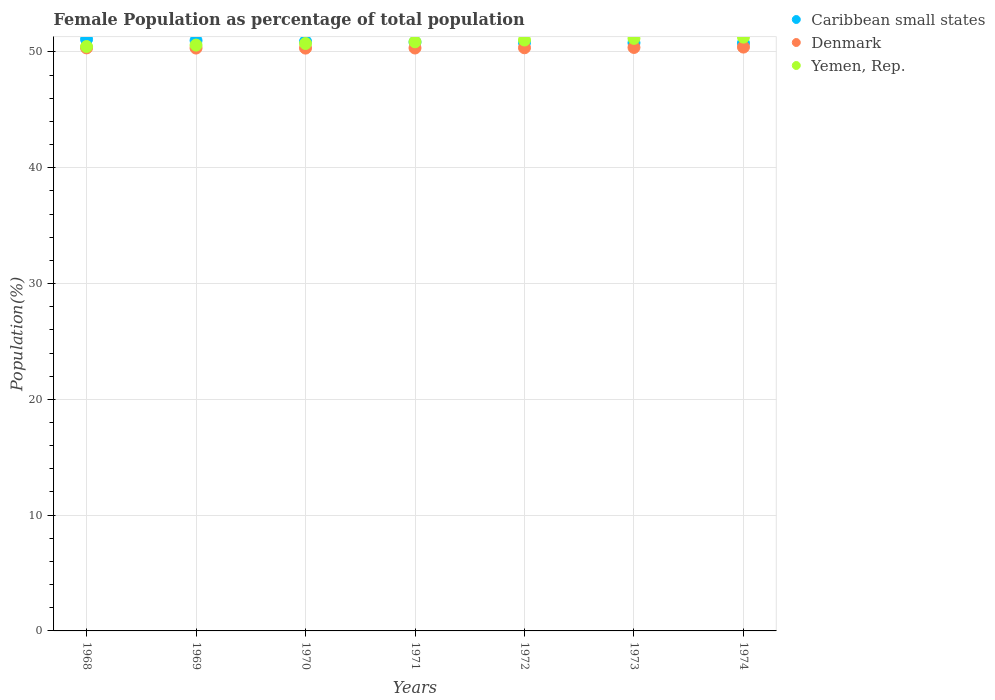How many different coloured dotlines are there?
Your answer should be very brief. 3. Is the number of dotlines equal to the number of legend labels?
Offer a very short reply. Yes. What is the female population in in Denmark in 1968?
Offer a terse response. 50.35. Across all years, what is the maximum female population in in Yemen, Rep.?
Give a very brief answer. 51.28. Across all years, what is the minimum female population in in Denmark?
Offer a very short reply. 50.33. In which year was the female population in in Caribbean small states maximum?
Provide a succinct answer. 1968. What is the total female population in in Denmark in the graph?
Provide a short and direct response. 352.52. What is the difference between the female population in in Yemen, Rep. in 1970 and that in 1973?
Your response must be concise. -0.44. What is the difference between the female population in in Caribbean small states in 1969 and the female population in in Yemen, Rep. in 1971?
Make the answer very short. 0.11. What is the average female population in in Denmark per year?
Offer a very short reply. 50.36. In the year 1971, what is the difference between the female population in in Yemen, Rep. and female population in in Caribbean small states?
Keep it short and to the point. 0.03. What is the ratio of the female population in in Yemen, Rep. in 1972 to that in 1973?
Your response must be concise. 1. Is the difference between the female population in in Yemen, Rep. in 1971 and 1973 greater than the difference between the female population in in Caribbean small states in 1971 and 1973?
Give a very brief answer. No. What is the difference between the highest and the second highest female population in in Denmark?
Offer a terse response. 0.03. What is the difference between the highest and the lowest female population in in Yemen, Rep.?
Offer a very short reply. 0.81. In how many years, is the female population in in Yemen, Rep. greater than the average female population in in Yemen, Rep. taken over all years?
Make the answer very short. 3. Is the female population in in Denmark strictly greater than the female population in in Yemen, Rep. over the years?
Keep it short and to the point. No. How many years are there in the graph?
Provide a short and direct response. 7. Are the values on the major ticks of Y-axis written in scientific E-notation?
Your answer should be very brief. No. Does the graph contain any zero values?
Provide a short and direct response. No. Does the graph contain grids?
Your response must be concise. Yes. What is the title of the graph?
Your answer should be very brief. Female Population as percentage of total population. Does "New Zealand" appear as one of the legend labels in the graph?
Offer a terse response. No. What is the label or title of the Y-axis?
Give a very brief answer. Population(%). What is the Population(%) in Caribbean small states in 1968?
Keep it short and to the point. 51.09. What is the Population(%) in Denmark in 1968?
Give a very brief answer. 50.35. What is the Population(%) in Yemen, Rep. in 1968?
Provide a short and direct response. 50.46. What is the Population(%) in Caribbean small states in 1969?
Provide a short and direct response. 50.99. What is the Population(%) of Denmark in 1969?
Provide a short and direct response. 50.33. What is the Population(%) of Yemen, Rep. in 1969?
Your answer should be compact. 50.59. What is the Population(%) in Caribbean small states in 1970?
Your answer should be very brief. 50.91. What is the Population(%) of Denmark in 1970?
Give a very brief answer. 50.33. What is the Population(%) of Yemen, Rep. in 1970?
Keep it short and to the point. 50.73. What is the Population(%) in Caribbean small states in 1971?
Provide a succinct answer. 50.85. What is the Population(%) in Denmark in 1971?
Offer a terse response. 50.34. What is the Population(%) of Yemen, Rep. in 1971?
Your answer should be compact. 50.88. What is the Population(%) in Caribbean small states in 1972?
Provide a short and direct response. 50.81. What is the Population(%) in Denmark in 1972?
Your answer should be compact. 50.36. What is the Population(%) of Yemen, Rep. in 1972?
Ensure brevity in your answer.  51.03. What is the Population(%) in Caribbean small states in 1973?
Provide a short and direct response. 50.78. What is the Population(%) of Denmark in 1973?
Keep it short and to the point. 50.39. What is the Population(%) of Yemen, Rep. in 1973?
Make the answer very short. 51.17. What is the Population(%) of Caribbean small states in 1974?
Your answer should be very brief. 50.76. What is the Population(%) in Denmark in 1974?
Offer a terse response. 50.42. What is the Population(%) of Yemen, Rep. in 1974?
Provide a short and direct response. 51.28. Across all years, what is the maximum Population(%) in Caribbean small states?
Your response must be concise. 51.09. Across all years, what is the maximum Population(%) in Denmark?
Keep it short and to the point. 50.42. Across all years, what is the maximum Population(%) of Yemen, Rep.?
Your response must be concise. 51.28. Across all years, what is the minimum Population(%) in Caribbean small states?
Your answer should be very brief. 50.76. Across all years, what is the minimum Population(%) in Denmark?
Keep it short and to the point. 50.33. Across all years, what is the minimum Population(%) in Yemen, Rep.?
Make the answer very short. 50.46. What is the total Population(%) of Caribbean small states in the graph?
Ensure brevity in your answer.  356.18. What is the total Population(%) of Denmark in the graph?
Provide a succinct answer. 352.52. What is the total Population(%) in Yemen, Rep. in the graph?
Offer a terse response. 356.14. What is the difference between the Population(%) of Caribbean small states in 1968 and that in 1969?
Ensure brevity in your answer.  0.1. What is the difference between the Population(%) in Denmark in 1968 and that in 1969?
Your response must be concise. 0.02. What is the difference between the Population(%) of Yemen, Rep. in 1968 and that in 1969?
Give a very brief answer. -0.13. What is the difference between the Population(%) of Caribbean small states in 1968 and that in 1970?
Offer a very short reply. 0.18. What is the difference between the Population(%) in Denmark in 1968 and that in 1970?
Provide a short and direct response. 0.02. What is the difference between the Population(%) of Yemen, Rep. in 1968 and that in 1970?
Your answer should be very brief. -0.26. What is the difference between the Population(%) in Caribbean small states in 1968 and that in 1971?
Provide a short and direct response. 0.24. What is the difference between the Population(%) in Denmark in 1968 and that in 1971?
Ensure brevity in your answer.  0.01. What is the difference between the Population(%) of Yemen, Rep. in 1968 and that in 1971?
Offer a terse response. -0.41. What is the difference between the Population(%) of Caribbean small states in 1968 and that in 1972?
Your answer should be very brief. 0.28. What is the difference between the Population(%) of Denmark in 1968 and that in 1972?
Keep it short and to the point. -0.01. What is the difference between the Population(%) of Yemen, Rep. in 1968 and that in 1972?
Your response must be concise. -0.57. What is the difference between the Population(%) of Caribbean small states in 1968 and that in 1973?
Your answer should be compact. 0.3. What is the difference between the Population(%) of Denmark in 1968 and that in 1973?
Offer a terse response. -0.04. What is the difference between the Population(%) of Yemen, Rep. in 1968 and that in 1973?
Your answer should be very brief. -0.71. What is the difference between the Population(%) in Caribbean small states in 1968 and that in 1974?
Provide a short and direct response. 0.33. What is the difference between the Population(%) of Denmark in 1968 and that in 1974?
Give a very brief answer. -0.07. What is the difference between the Population(%) of Yemen, Rep. in 1968 and that in 1974?
Give a very brief answer. -0.81. What is the difference between the Population(%) of Caribbean small states in 1969 and that in 1970?
Ensure brevity in your answer.  0.08. What is the difference between the Population(%) of Denmark in 1969 and that in 1970?
Keep it short and to the point. 0. What is the difference between the Population(%) in Yemen, Rep. in 1969 and that in 1970?
Offer a terse response. -0.14. What is the difference between the Population(%) of Caribbean small states in 1969 and that in 1971?
Make the answer very short. 0.14. What is the difference between the Population(%) in Denmark in 1969 and that in 1971?
Give a very brief answer. -0.01. What is the difference between the Population(%) in Yemen, Rep. in 1969 and that in 1971?
Your response must be concise. -0.28. What is the difference between the Population(%) in Caribbean small states in 1969 and that in 1972?
Provide a short and direct response. 0.18. What is the difference between the Population(%) of Denmark in 1969 and that in 1972?
Ensure brevity in your answer.  -0.03. What is the difference between the Population(%) in Yemen, Rep. in 1969 and that in 1972?
Provide a succinct answer. -0.44. What is the difference between the Population(%) of Caribbean small states in 1969 and that in 1973?
Keep it short and to the point. 0.2. What is the difference between the Population(%) in Denmark in 1969 and that in 1973?
Give a very brief answer. -0.05. What is the difference between the Population(%) of Yemen, Rep. in 1969 and that in 1973?
Provide a short and direct response. -0.58. What is the difference between the Population(%) in Caribbean small states in 1969 and that in 1974?
Give a very brief answer. 0.23. What is the difference between the Population(%) in Denmark in 1969 and that in 1974?
Your answer should be compact. -0.08. What is the difference between the Population(%) of Yemen, Rep. in 1969 and that in 1974?
Offer a very short reply. -0.69. What is the difference between the Population(%) of Caribbean small states in 1970 and that in 1971?
Provide a short and direct response. 0.06. What is the difference between the Population(%) of Denmark in 1970 and that in 1971?
Ensure brevity in your answer.  -0.01. What is the difference between the Population(%) in Yemen, Rep. in 1970 and that in 1971?
Provide a short and direct response. -0.15. What is the difference between the Population(%) of Caribbean small states in 1970 and that in 1972?
Your answer should be very brief. 0.1. What is the difference between the Population(%) in Denmark in 1970 and that in 1972?
Give a very brief answer. -0.03. What is the difference between the Population(%) of Yemen, Rep. in 1970 and that in 1972?
Give a very brief answer. -0.3. What is the difference between the Population(%) of Caribbean small states in 1970 and that in 1973?
Keep it short and to the point. 0.12. What is the difference between the Population(%) in Denmark in 1970 and that in 1973?
Make the answer very short. -0.06. What is the difference between the Population(%) in Yemen, Rep. in 1970 and that in 1973?
Your answer should be compact. -0.44. What is the difference between the Population(%) of Caribbean small states in 1970 and that in 1974?
Keep it short and to the point. 0.14. What is the difference between the Population(%) of Denmark in 1970 and that in 1974?
Give a very brief answer. -0.09. What is the difference between the Population(%) in Yemen, Rep. in 1970 and that in 1974?
Give a very brief answer. -0.55. What is the difference between the Population(%) in Caribbean small states in 1971 and that in 1972?
Provide a short and direct response. 0.04. What is the difference between the Population(%) of Denmark in 1971 and that in 1972?
Offer a very short reply. -0.02. What is the difference between the Population(%) in Yemen, Rep. in 1971 and that in 1972?
Ensure brevity in your answer.  -0.15. What is the difference between the Population(%) of Caribbean small states in 1971 and that in 1973?
Make the answer very short. 0.06. What is the difference between the Population(%) in Denmark in 1971 and that in 1973?
Make the answer very short. -0.05. What is the difference between the Population(%) of Yemen, Rep. in 1971 and that in 1973?
Make the answer very short. -0.3. What is the difference between the Population(%) of Caribbean small states in 1971 and that in 1974?
Your answer should be very brief. 0.09. What is the difference between the Population(%) of Denmark in 1971 and that in 1974?
Make the answer very short. -0.08. What is the difference between the Population(%) in Yemen, Rep. in 1971 and that in 1974?
Your answer should be compact. -0.4. What is the difference between the Population(%) of Caribbean small states in 1972 and that in 1973?
Ensure brevity in your answer.  0.03. What is the difference between the Population(%) in Denmark in 1972 and that in 1973?
Give a very brief answer. -0.03. What is the difference between the Population(%) in Yemen, Rep. in 1972 and that in 1973?
Offer a terse response. -0.14. What is the difference between the Population(%) in Caribbean small states in 1972 and that in 1974?
Offer a terse response. 0.05. What is the difference between the Population(%) of Denmark in 1972 and that in 1974?
Give a very brief answer. -0.06. What is the difference between the Population(%) of Yemen, Rep. in 1972 and that in 1974?
Provide a short and direct response. -0.25. What is the difference between the Population(%) in Caribbean small states in 1973 and that in 1974?
Your response must be concise. 0.02. What is the difference between the Population(%) in Denmark in 1973 and that in 1974?
Provide a short and direct response. -0.03. What is the difference between the Population(%) in Yemen, Rep. in 1973 and that in 1974?
Keep it short and to the point. -0.11. What is the difference between the Population(%) in Caribbean small states in 1968 and the Population(%) in Denmark in 1969?
Offer a very short reply. 0.75. What is the difference between the Population(%) of Caribbean small states in 1968 and the Population(%) of Yemen, Rep. in 1969?
Ensure brevity in your answer.  0.5. What is the difference between the Population(%) of Denmark in 1968 and the Population(%) of Yemen, Rep. in 1969?
Your answer should be compact. -0.24. What is the difference between the Population(%) of Caribbean small states in 1968 and the Population(%) of Denmark in 1970?
Your answer should be very brief. 0.76. What is the difference between the Population(%) in Caribbean small states in 1968 and the Population(%) in Yemen, Rep. in 1970?
Ensure brevity in your answer.  0.36. What is the difference between the Population(%) in Denmark in 1968 and the Population(%) in Yemen, Rep. in 1970?
Your response must be concise. -0.38. What is the difference between the Population(%) in Caribbean small states in 1968 and the Population(%) in Denmark in 1971?
Your answer should be compact. 0.75. What is the difference between the Population(%) in Caribbean small states in 1968 and the Population(%) in Yemen, Rep. in 1971?
Your answer should be compact. 0.21. What is the difference between the Population(%) in Denmark in 1968 and the Population(%) in Yemen, Rep. in 1971?
Your answer should be very brief. -0.53. What is the difference between the Population(%) in Caribbean small states in 1968 and the Population(%) in Denmark in 1972?
Ensure brevity in your answer.  0.73. What is the difference between the Population(%) of Caribbean small states in 1968 and the Population(%) of Yemen, Rep. in 1972?
Your answer should be very brief. 0.06. What is the difference between the Population(%) in Denmark in 1968 and the Population(%) in Yemen, Rep. in 1972?
Offer a terse response. -0.68. What is the difference between the Population(%) in Caribbean small states in 1968 and the Population(%) in Denmark in 1973?
Offer a very short reply. 0.7. What is the difference between the Population(%) in Caribbean small states in 1968 and the Population(%) in Yemen, Rep. in 1973?
Provide a short and direct response. -0.08. What is the difference between the Population(%) of Denmark in 1968 and the Population(%) of Yemen, Rep. in 1973?
Provide a succinct answer. -0.82. What is the difference between the Population(%) of Caribbean small states in 1968 and the Population(%) of Denmark in 1974?
Give a very brief answer. 0.67. What is the difference between the Population(%) in Caribbean small states in 1968 and the Population(%) in Yemen, Rep. in 1974?
Your answer should be very brief. -0.19. What is the difference between the Population(%) in Denmark in 1968 and the Population(%) in Yemen, Rep. in 1974?
Keep it short and to the point. -0.93. What is the difference between the Population(%) in Caribbean small states in 1969 and the Population(%) in Denmark in 1970?
Ensure brevity in your answer.  0.66. What is the difference between the Population(%) in Caribbean small states in 1969 and the Population(%) in Yemen, Rep. in 1970?
Provide a succinct answer. 0.26. What is the difference between the Population(%) in Denmark in 1969 and the Population(%) in Yemen, Rep. in 1970?
Offer a very short reply. -0.39. What is the difference between the Population(%) of Caribbean small states in 1969 and the Population(%) of Denmark in 1971?
Give a very brief answer. 0.65. What is the difference between the Population(%) of Caribbean small states in 1969 and the Population(%) of Yemen, Rep. in 1971?
Ensure brevity in your answer.  0.11. What is the difference between the Population(%) of Denmark in 1969 and the Population(%) of Yemen, Rep. in 1971?
Offer a terse response. -0.54. What is the difference between the Population(%) of Caribbean small states in 1969 and the Population(%) of Denmark in 1972?
Ensure brevity in your answer.  0.63. What is the difference between the Population(%) of Caribbean small states in 1969 and the Population(%) of Yemen, Rep. in 1972?
Your response must be concise. -0.04. What is the difference between the Population(%) in Denmark in 1969 and the Population(%) in Yemen, Rep. in 1972?
Your answer should be very brief. -0.7. What is the difference between the Population(%) in Caribbean small states in 1969 and the Population(%) in Denmark in 1973?
Ensure brevity in your answer.  0.6. What is the difference between the Population(%) in Caribbean small states in 1969 and the Population(%) in Yemen, Rep. in 1973?
Provide a succinct answer. -0.18. What is the difference between the Population(%) of Denmark in 1969 and the Population(%) of Yemen, Rep. in 1973?
Ensure brevity in your answer.  -0.84. What is the difference between the Population(%) in Caribbean small states in 1969 and the Population(%) in Denmark in 1974?
Your answer should be compact. 0.57. What is the difference between the Population(%) of Caribbean small states in 1969 and the Population(%) of Yemen, Rep. in 1974?
Keep it short and to the point. -0.29. What is the difference between the Population(%) in Denmark in 1969 and the Population(%) in Yemen, Rep. in 1974?
Give a very brief answer. -0.94. What is the difference between the Population(%) of Caribbean small states in 1970 and the Population(%) of Denmark in 1971?
Provide a short and direct response. 0.57. What is the difference between the Population(%) of Caribbean small states in 1970 and the Population(%) of Yemen, Rep. in 1971?
Ensure brevity in your answer.  0.03. What is the difference between the Population(%) in Denmark in 1970 and the Population(%) in Yemen, Rep. in 1971?
Your response must be concise. -0.55. What is the difference between the Population(%) of Caribbean small states in 1970 and the Population(%) of Denmark in 1972?
Ensure brevity in your answer.  0.55. What is the difference between the Population(%) of Caribbean small states in 1970 and the Population(%) of Yemen, Rep. in 1972?
Offer a very short reply. -0.12. What is the difference between the Population(%) in Denmark in 1970 and the Population(%) in Yemen, Rep. in 1972?
Your response must be concise. -0.7. What is the difference between the Population(%) of Caribbean small states in 1970 and the Population(%) of Denmark in 1973?
Keep it short and to the point. 0.52. What is the difference between the Population(%) in Caribbean small states in 1970 and the Population(%) in Yemen, Rep. in 1973?
Keep it short and to the point. -0.27. What is the difference between the Population(%) of Denmark in 1970 and the Population(%) of Yemen, Rep. in 1973?
Offer a terse response. -0.84. What is the difference between the Population(%) in Caribbean small states in 1970 and the Population(%) in Denmark in 1974?
Offer a terse response. 0.49. What is the difference between the Population(%) in Caribbean small states in 1970 and the Population(%) in Yemen, Rep. in 1974?
Ensure brevity in your answer.  -0.37. What is the difference between the Population(%) in Denmark in 1970 and the Population(%) in Yemen, Rep. in 1974?
Your answer should be compact. -0.95. What is the difference between the Population(%) of Caribbean small states in 1971 and the Population(%) of Denmark in 1972?
Make the answer very short. 0.49. What is the difference between the Population(%) in Caribbean small states in 1971 and the Population(%) in Yemen, Rep. in 1972?
Your response must be concise. -0.18. What is the difference between the Population(%) of Denmark in 1971 and the Population(%) of Yemen, Rep. in 1972?
Your answer should be very brief. -0.69. What is the difference between the Population(%) in Caribbean small states in 1971 and the Population(%) in Denmark in 1973?
Your response must be concise. 0.46. What is the difference between the Population(%) of Caribbean small states in 1971 and the Population(%) of Yemen, Rep. in 1973?
Offer a very short reply. -0.32. What is the difference between the Population(%) in Denmark in 1971 and the Population(%) in Yemen, Rep. in 1973?
Make the answer very short. -0.83. What is the difference between the Population(%) in Caribbean small states in 1971 and the Population(%) in Denmark in 1974?
Make the answer very short. 0.43. What is the difference between the Population(%) of Caribbean small states in 1971 and the Population(%) of Yemen, Rep. in 1974?
Offer a terse response. -0.43. What is the difference between the Population(%) of Denmark in 1971 and the Population(%) of Yemen, Rep. in 1974?
Provide a succinct answer. -0.94. What is the difference between the Population(%) in Caribbean small states in 1972 and the Population(%) in Denmark in 1973?
Keep it short and to the point. 0.42. What is the difference between the Population(%) in Caribbean small states in 1972 and the Population(%) in Yemen, Rep. in 1973?
Your answer should be very brief. -0.36. What is the difference between the Population(%) of Denmark in 1972 and the Population(%) of Yemen, Rep. in 1973?
Provide a short and direct response. -0.81. What is the difference between the Population(%) in Caribbean small states in 1972 and the Population(%) in Denmark in 1974?
Your answer should be compact. 0.39. What is the difference between the Population(%) in Caribbean small states in 1972 and the Population(%) in Yemen, Rep. in 1974?
Offer a very short reply. -0.47. What is the difference between the Population(%) in Denmark in 1972 and the Population(%) in Yemen, Rep. in 1974?
Your answer should be very brief. -0.92. What is the difference between the Population(%) of Caribbean small states in 1973 and the Population(%) of Denmark in 1974?
Provide a succinct answer. 0.37. What is the difference between the Population(%) of Caribbean small states in 1973 and the Population(%) of Yemen, Rep. in 1974?
Your response must be concise. -0.49. What is the difference between the Population(%) of Denmark in 1973 and the Population(%) of Yemen, Rep. in 1974?
Your response must be concise. -0.89. What is the average Population(%) of Caribbean small states per year?
Your answer should be very brief. 50.88. What is the average Population(%) in Denmark per year?
Provide a short and direct response. 50.36. What is the average Population(%) in Yemen, Rep. per year?
Your answer should be compact. 50.88. In the year 1968, what is the difference between the Population(%) of Caribbean small states and Population(%) of Denmark?
Your answer should be very brief. 0.74. In the year 1968, what is the difference between the Population(%) in Caribbean small states and Population(%) in Yemen, Rep.?
Offer a very short reply. 0.62. In the year 1968, what is the difference between the Population(%) of Denmark and Population(%) of Yemen, Rep.?
Your answer should be very brief. -0.11. In the year 1969, what is the difference between the Population(%) in Caribbean small states and Population(%) in Denmark?
Your answer should be compact. 0.65. In the year 1969, what is the difference between the Population(%) in Caribbean small states and Population(%) in Yemen, Rep.?
Your response must be concise. 0.4. In the year 1969, what is the difference between the Population(%) of Denmark and Population(%) of Yemen, Rep.?
Give a very brief answer. -0.26. In the year 1970, what is the difference between the Population(%) of Caribbean small states and Population(%) of Denmark?
Give a very brief answer. 0.58. In the year 1970, what is the difference between the Population(%) in Caribbean small states and Population(%) in Yemen, Rep.?
Your answer should be very brief. 0.18. In the year 1970, what is the difference between the Population(%) of Denmark and Population(%) of Yemen, Rep.?
Keep it short and to the point. -0.4. In the year 1971, what is the difference between the Population(%) of Caribbean small states and Population(%) of Denmark?
Provide a short and direct response. 0.51. In the year 1971, what is the difference between the Population(%) of Caribbean small states and Population(%) of Yemen, Rep.?
Offer a very short reply. -0.03. In the year 1971, what is the difference between the Population(%) in Denmark and Population(%) in Yemen, Rep.?
Offer a very short reply. -0.54. In the year 1972, what is the difference between the Population(%) in Caribbean small states and Population(%) in Denmark?
Give a very brief answer. 0.45. In the year 1972, what is the difference between the Population(%) of Caribbean small states and Population(%) of Yemen, Rep.?
Provide a succinct answer. -0.22. In the year 1972, what is the difference between the Population(%) of Denmark and Population(%) of Yemen, Rep.?
Offer a very short reply. -0.67. In the year 1973, what is the difference between the Population(%) in Caribbean small states and Population(%) in Denmark?
Your response must be concise. 0.4. In the year 1973, what is the difference between the Population(%) in Caribbean small states and Population(%) in Yemen, Rep.?
Ensure brevity in your answer.  -0.39. In the year 1973, what is the difference between the Population(%) in Denmark and Population(%) in Yemen, Rep.?
Your answer should be very brief. -0.78. In the year 1974, what is the difference between the Population(%) in Caribbean small states and Population(%) in Denmark?
Offer a very short reply. 0.34. In the year 1974, what is the difference between the Population(%) in Caribbean small states and Population(%) in Yemen, Rep.?
Your answer should be compact. -0.52. In the year 1974, what is the difference between the Population(%) in Denmark and Population(%) in Yemen, Rep.?
Offer a very short reply. -0.86. What is the ratio of the Population(%) in Caribbean small states in 1968 to that in 1969?
Offer a terse response. 1. What is the ratio of the Population(%) of Denmark in 1968 to that in 1970?
Make the answer very short. 1. What is the ratio of the Population(%) in Yemen, Rep. in 1968 to that in 1970?
Ensure brevity in your answer.  0.99. What is the ratio of the Population(%) in Caribbean small states in 1968 to that in 1971?
Your response must be concise. 1. What is the ratio of the Population(%) of Caribbean small states in 1968 to that in 1972?
Provide a short and direct response. 1.01. What is the ratio of the Population(%) of Denmark in 1968 to that in 1972?
Keep it short and to the point. 1. What is the ratio of the Population(%) in Yemen, Rep. in 1968 to that in 1972?
Your response must be concise. 0.99. What is the ratio of the Population(%) in Caribbean small states in 1968 to that in 1973?
Keep it short and to the point. 1.01. What is the ratio of the Population(%) in Yemen, Rep. in 1968 to that in 1973?
Ensure brevity in your answer.  0.99. What is the ratio of the Population(%) in Caribbean small states in 1968 to that in 1974?
Offer a terse response. 1.01. What is the ratio of the Population(%) in Denmark in 1968 to that in 1974?
Your response must be concise. 1. What is the ratio of the Population(%) in Yemen, Rep. in 1968 to that in 1974?
Keep it short and to the point. 0.98. What is the ratio of the Population(%) in Caribbean small states in 1969 to that in 1970?
Provide a short and direct response. 1. What is the ratio of the Population(%) in Denmark in 1969 to that in 1970?
Ensure brevity in your answer.  1. What is the ratio of the Population(%) in Yemen, Rep. in 1969 to that in 1970?
Give a very brief answer. 1. What is the ratio of the Population(%) in Caribbean small states in 1969 to that in 1971?
Give a very brief answer. 1. What is the ratio of the Population(%) in Denmark in 1969 to that in 1971?
Ensure brevity in your answer.  1. What is the ratio of the Population(%) in Yemen, Rep. in 1969 to that in 1971?
Provide a succinct answer. 0.99. What is the ratio of the Population(%) of Caribbean small states in 1969 to that in 1973?
Keep it short and to the point. 1. What is the ratio of the Population(%) of Yemen, Rep. in 1969 to that in 1973?
Offer a very short reply. 0.99. What is the ratio of the Population(%) in Denmark in 1969 to that in 1974?
Make the answer very short. 1. What is the ratio of the Population(%) in Yemen, Rep. in 1969 to that in 1974?
Offer a terse response. 0.99. What is the ratio of the Population(%) of Yemen, Rep. in 1970 to that in 1972?
Keep it short and to the point. 0.99. What is the ratio of the Population(%) in Denmark in 1970 to that in 1973?
Provide a short and direct response. 1. What is the ratio of the Population(%) in Yemen, Rep. in 1970 to that in 1973?
Your answer should be very brief. 0.99. What is the ratio of the Population(%) of Caribbean small states in 1970 to that in 1974?
Provide a short and direct response. 1. What is the ratio of the Population(%) of Denmark in 1970 to that in 1974?
Give a very brief answer. 1. What is the ratio of the Population(%) in Yemen, Rep. in 1970 to that in 1974?
Ensure brevity in your answer.  0.99. What is the ratio of the Population(%) in Denmark in 1971 to that in 1973?
Keep it short and to the point. 1. What is the ratio of the Population(%) in Caribbean small states in 1971 to that in 1974?
Your answer should be compact. 1. What is the ratio of the Population(%) in Caribbean small states in 1972 to that in 1973?
Ensure brevity in your answer.  1. What is the ratio of the Population(%) of Caribbean small states in 1972 to that in 1974?
Your response must be concise. 1. What is the ratio of the Population(%) in Denmark in 1972 to that in 1974?
Your answer should be compact. 1. What is the ratio of the Population(%) of Yemen, Rep. in 1972 to that in 1974?
Your response must be concise. 1. What is the ratio of the Population(%) of Caribbean small states in 1973 to that in 1974?
Ensure brevity in your answer.  1. What is the difference between the highest and the second highest Population(%) in Caribbean small states?
Your response must be concise. 0.1. What is the difference between the highest and the second highest Population(%) in Denmark?
Keep it short and to the point. 0.03. What is the difference between the highest and the second highest Population(%) of Yemen, Rep.?
Your response must be concise. 0.11. What is the difference between the highest and the lowest Population(%) of Caribbean small states?
Make the answer very short. 0.33. What is the difference between the highest and the lowest Population(%) in Denmark?
Your response must be concise. 0.09. What is the difference between the highest and the lowest Population(%) of Yemen, Rep.?
Make the answer very short. 0.81. 